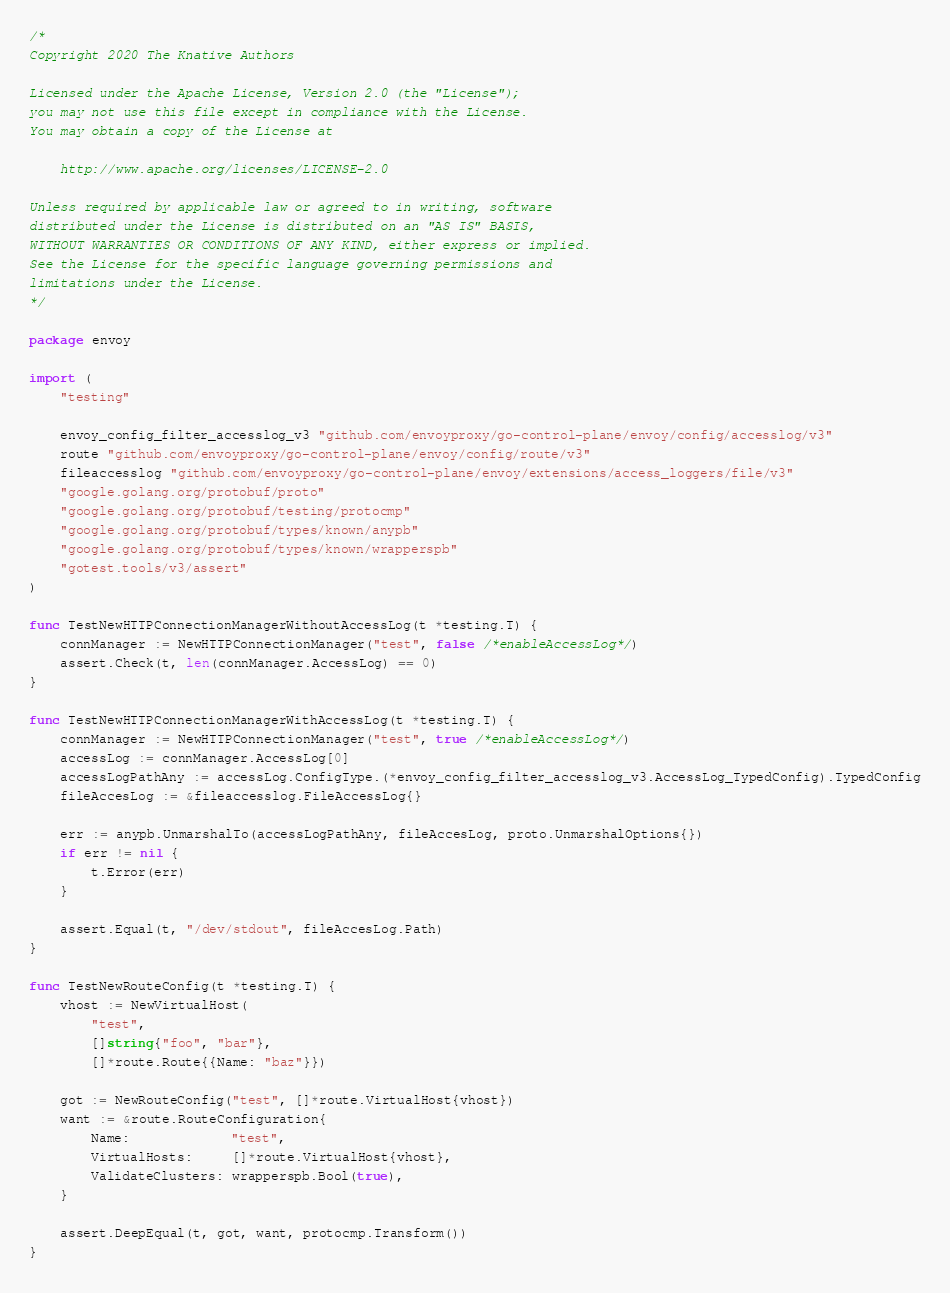Convert code to text. <code><loc_0><loc_0><loc_500><loc_500><_Go_>/*
Copyright 2020 The Knative Authors

Licensed under the Apache License, Version 2.0 (the "License");
you may not use this file except in compliance with the License.
You may obtain a copy of the License at

    http://www.apache.org/licenses/LICENSE-2.0

Unless required by applicable law or agreed to in writing, software
distributed under the License is distributed on an "AS IS" BASIS,
WITHOUT WARRANTIES OR CONDITIONS OF ANY KIND, either express or implied.
See the License for the specific language governing permissions and
limitations under the License.
*/

package envoy

import (
	"testing"

	envoy_config_filter_accesslog_v3 "github.com/envoyproxy/go-control-plane/envoy/config/accesslog/v3"
	route "github.com/envoyproxy/go-control-plane/envoy/config/route/v3"
	fileaccesslog "github.com/envoyproxy/go-control-plane/envoy/extensions/access_loggers/file/v3"
	"google.golang.org/protobuf/proto"
	"google.golang.org/protobuf/testing/protocmp"
	"google.golang.org/protobuf/types/known/anypb"
	"google.golang.org/protobuf/types/known/wrapperspb"
	"gotest.tools/v3/assert"
)

func TestNewHTTPConnectionManagerWithoutAccessLog(t *testing.T) {
	connManager := NewHTTPConnectionManager("test", false /*enableAccessLog*/)
	assert.Check(t, len(connManager.AccessLog) == 0)
}

func TestNewHTTPConnectionManagerWithAccessLog(t *testing.T) {
	connManager := NewHTTPConnectionManager("test", true /*enableAccessLog*/)
	accessLog := connManager.AccessLog[0]
	accessLogPathAny := accessLog.ConfigType.(*envoy_config_filter_accesslog_v3.AccessLog_TypedConfig).TypedConfig
	fileAccesLog := &fileaccesslog.FileAccessLog{}

	err := anypb.UnmarshalTo(accessLogPathAny, fileAccesLog, proto.UnmarshalOptions{})
	if err != nil {
		t.Error(err)
	}

	assert.Equal(t, "/dev/stdout", fileAccesLog.Path)
}

func TestNewRouteConfig(t *testing.T) {
	vhost := NewVirtualHost(
		"test",
		[]string{"foo", "bar"},
		[]*route.Route{{Name: "baz"}})

	got := NewRouteConfig("test", []*route.VirtualHost{vhost})
	want := &route.RouteConfiguration{
		Name:             "test",
		VirtualHosts:     []*route.VirtualHost{vhost},
		ValidateClusters: wrapperspb.Bool(true),
	}

	assert.DeepEqual(t, got, want, protocmp.Transform())
}
</code> 